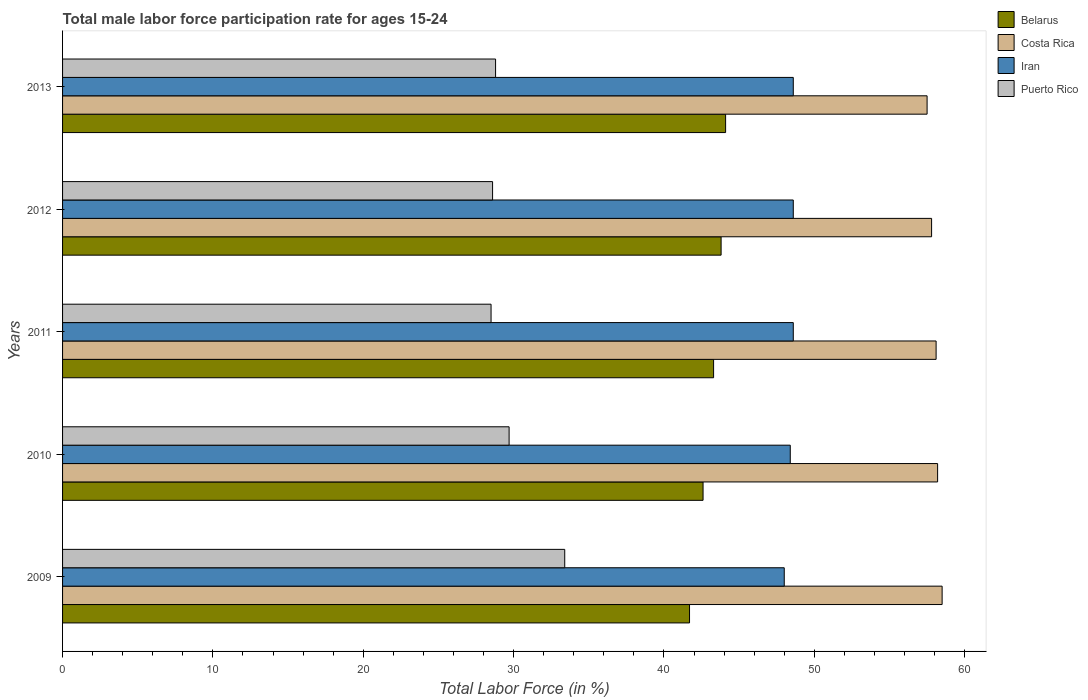How many groups of bars are there?
Your answer should be compact. 5. Are the number of bars on each tick of the Y-axis equal?
Offer a terse response. Yes. How many bars are there on the 1st tick from the bottom?
Ensure brevity in your answer.  4. What is the label of the 3rd group of bars from the top?
Your answer should be very brief. 2011. What is the male labor force participation rate in Costa Rica in 2013?
Give a very brief answer. 57.5. Across all years, what is the maximum male labor force participation rate in Iran?
Offer a terse response. 48.6. Across all years, what is the minimum male labor force participation rate in Belarus?
Make the answer very short. 41.7. In which year was the male labor force participation rate in Puerto Rico maximum?
Your response must be concise. 2009. In which year was the male labor force participation rate in Iran minimum?
Give a very brief answer. 2009. What is the total male labor force participation rate in Iran in the graph?
Your answer should be very brief. 242.2. What is the difference between the male labor force participation rate in Costa Rica in 2010 and that in 2013?
Your response must be concise. 0.7. What is the difference between the male labor force participation rate in Puerto Rico in 2009 and the male labor force participation rate in Iran in 2012?
Provide a succinct answer. -15.2. What is the average male labor force participation rate in Belarus per year?
Offer a terse response. 43.1. In the year 2011, what is the difference between the male labor force participation rate in Iran and male labor force participation rate in Belarus?
Offer a terse response. 5.3. Is the difference between the male labor force participation rate in Iran in 2012 and 2013 greater than the difference between the male labor force participation rate in Belarus in 2012 and 2013?
Your answer should be very brief. Yes. What is the difference between the highest and the second highest male labor force participation rate in Puerto Rico?
Your answer should be very brief. 3.7. What is the difference between the highest and the lowest male labor force participation rate in Costa Rica?
Provide a short and direct response. 1. Is the sum of the male labor force participation rate in Puerto Rico in 2009 and 2013 greater than the maximum male labor force participation rate in Belarus across all years?
Make the answer very short. Yes. What does the 2nd bar from the top in 2011 represents?
Offer a terse response. Iran. What does the 1st bar from the bottom in 2011 represents?
Offer a terse response. Belarus. How many bars are there?
Make the answer very short. 20. Are all the bars in the graph horizontal?
Your answer should be compact. Yes. What is the difference between two consecutive major ticks on the X-axis?
Keep it short and to the point. 10. Does the graph contain grids?
Provide a succinct answer. No. How many legend labels are there?
Offer a very short reply. 4. What is the title of the graph?
Your answer should be compact. Total male labor force participation rate for ages 15-24. What is the label or title of the X-axis?
Your answer should be compact. Total Labor Force (in %). What is the Total Labor Force (in %) in Belarus in 2009?
Your answer should be very brief. 41.7. What is the Total Labor Force (in %) of Costa Rica in 2009?
Your answer should be very brief. 58.5. What is the Total Labor Force (in %) in Puerto Rico in 2009?
Offer a terse response. 33.4. What is the Total Labor Force (in %) of Belarus in 2010?
Your answer should be very brief. 42.6. What is the Total Labor Force (in %) in Costa Rica in 2010?
Offer a very short reply. 58.2. What is the Total Labor Force (in %) of Iran in 2010?
Offer a terse response. 48.4. What is the Total Labor Force (in %) of Puerto Rico in 2010?
Ensure brevity in your answer.  29.7. What is the Total Labor Force (in %) in Belarus in 2011?
Your response must be concise. 43.3. What is the Total Labor Force (in %) in Costa Rica in 2011?
Ensure brevity in your answer.  58.1. What is the Total Labor Force (in %) in Iran in 2011?
Provide a short and direct response. 48.6. What is the Total Labor Force (in %) of Belarus in 2012?
Make the answer very short. 43.8. What is the Total Labor Force (in %) in Costa Rica in 2012?
Ensure brevity in your answer.  57.8. What is the Total Labor Force (in %) of Iran in 2012?
Offer a very short reply. 48.6. What is the Total Labor Force (in %) of Puerto Rico in 2012?
Ensure brevity in your answer.  28.6. What is the Total Labor Force (in %) in Belarus in 2013?
Provide a succinct answer. 44.1. What is the Total Labor Force (in %) of Costa Rica in 2013?
Your response must be concise. 57.5. What is the Total Labor Force (in %) of Iran in 2013?
Your response must be concise. 48.6. What is the Total Labor Force (in %) of Puerto Rico in 2013?
Provide a succinct answer. 28.8. Across all years, what is the maximum Total Labor Force (in %) in Belarus?
Give a very brief answer. 44.1. Across all years, what is the maximum Total Labor Force (in %) in Costa Rica?
Your answer should be very brief. 58.5. Across all years, what is the maximum Total Labor Force (in %) of Iran?
Give a very brief answer. 48.6. Across all years, what is the maximum Total Labor Force (in %) in Puerto Rico?
Offer a terse response. 33.4. Across all years, what is the minimum Total Labor Force (in %) in Belarus?
Offer a terse response. 41.7. Across all years, what is the minimum Total Labor Force (in %) of Costa Rica?
Offer a very short reply. 57.5. Across all years, what is the minimum Total Labor Force (in %) in Iran?
Keep it short and to the point. 48. What is the total Total Labor Force (in %) of Belarus in the graph?
Your answer should be very brief. 215.5. What is the total Total Labor Force (in %) in Costa Rica in the graph?
Your answer should be compact. 290.1. What is the total Total Labor Force (in %) in Iran in the graph?
Make the answer very short. 242.2. What is the total Total Labor Force (in %) of Puerto Rico in the graph?
Your answer should be very brief. 149. What is the difference between the Total Labor Force (in %) of Costa Rica in 2009 and that in 2010?
Offer a very short reply. 0.3. What is the difference between the Total Labor Force (in %) of Belarus in 2009 and that in 2011?
Ensure brevity in your answer.  -1.6. What is the difference between the Total Labor Force (in %) of Costa Rica in 2009 and that in 2011?
Your answer should be very brief. 0.4. What is the difference between the Total Labor Force (in %) of Puerto Rico in 2009 and that in 2011?
Make the answer very short. 4.9. What is the difference between the Total Labor Force (in %) in Iran in 2009 and that in 2012?
Offer a very short reply. -0.6. What is the difference between the Total Labor Force (in %) in Costa Rica in 2009 and that in 2013?
Ensure brevity in your answer.  1. What is the difference between the Total Labor Force (in %) of Iran in 2009 and that in 2013?
Provide a short and direct response. -0.6. What is the difference between the Total Labor Force (in %) of Costa Rica in 2010 and that in 2011?
Your response must be concise. 0.1. What is the difference between the Total Labor Force (in %) in Iran in 2010 and that in 2011?
Your response must be concise. -0.2. What is the difference between the Total Labor Force (in %) in Iran in 2010 and that in 2012?
Your answer should be compact. -0.2. What is the difference between the Total Labor Force (in %) of Puerto Rico in 2010 and that in 2012?
Your answer should be compact. 1.1. What is the difference between the Total Labor Force (in %) in Belarus in 2010 and that in 2013?
Your response must be concise. -1.5. What is the difference between the Total Labor Force (in %) of Puerto Rico in 2010 and that in 2013?
Your answer should be very brief. 0.9. What is the difference between the Total Labor Force (in %) in Belarus in 2011 and that in 2012?
Make the answer very short. -0.5. What is the difference between the Total Labor Force (in %) of Costa Rica in 2011 and that in 2012?
Provide a succinct answer. 0.3. What is the difference between the Total Labor Force (in %) in Costa Rica in 2011 and that in 2013?
Your answer should be compact. 0.6. What is the difference between the Total Labor Force (in %) in Iran in 2011 and that in 2013?
Your answer should be compact. 0. What is the difference between the Total Labor Force (in %) in Belarus in 2012 and that in 2013?
Your answer should be very brief. -0.3. What is the difference between the Total Labor Force (in %) in Costa Rica in 2012 and that in 2013?
Offer a very short reply. 0.3. What is the difference between the Total Labor Force (in %) in Iran in 2012 and that in 2013?
Your answer should be compact. 0. What is the difference between the Total Labor Force (in %) in Belarus in 2009 and the Total Labor Force (in %) in Costa Rica in 2010?
Offer a very short reply. -16.5. What is the difference between the Total Labor Force (in %) in Costa Rica in 2009 and the Total Labor Force (in %) in Iran in 2010?
Give a very brief answer. 10.1. What is the difference between the Total Labor Force (in %) of Costa Rica in 2009 and the Total Labor Force (in %) of Puerto Rico in 2010?
Offer a terse response. 28.8. What is the difference between the Total Labor Force (in %) in Iran in 2009 and the Total Labor Force (in %) in Puerto Rico in 2010?
Keep it short and to the point. 18.3. What is the difference between the Total Labor Force (in %) of Belarus in 2009 and the Total Labor Force (in %) of Costa Rica in 2011?
Provide a short and direct response. -16.4. What is the difference between the Total Labor Force (in %) of Costa Rica in 2009 and the Total Labor Force (in %) of Iran in 2011?
Keep it short and to the point. 9.9. What is the difference between the Total Labor Force (in %) of Costa Rica in 2009 and the Total Labor Force (in %) of Puerto Rico in 2011?
Your answer should be compact. 30. What is the difference between the Total Labor Force (in %) of Iran in 2009 and the Total Labor Force (in %) of Puerto Rico in 2011?
Provide a succinct answer. 19.5. What is the difference between the Total Labor Force (in %) in Belarus in 2009 and the Total Labor Force (in %) in Costa Rica in 2012?
Provide a short and direct response. -16.1. What is the difference between the Total Labor Force (in %) in Belarus in 2009 and the Total Labor Force (in %) in Puerto Rico in 2012?
Provide a short and direct response. 13.1. What is the difference between the Total Labor Force (in %) in Costa Rica in 2009 and the Total Labor Force (in %) in Iran in 2012?
Give a very brief answer. 9.9. What is the difference between the Total Labor Force (in %) in Costa Rica in 2009 and the Total Labor Force (in %) in Puerto Rico in 2012?
Offer a terse response. 29.9. What is the difference between the Total Labor Force (in %) in Belarus in 2009 and the Total Labor Force (in %) in Costa Rica in 2013?
Ensure brevity in your answer.  -15.8. What is the difference between the Total Labor Force (in %) in Belarus in 2009 and the Total Labor Force (in %) in Puerto Rico in 2013?
Provide a succinct answer. 12.9. What is the difference between the Total Labor Force (in %) in Costa Rica in 2009 and the Total Labor Force (in %) in Puerto Rico in 2013?
Make the answer very short. 29.7. What is the difference between the Total Labor Force (in %) of Iran in 2009 and the Total Labor Force (in %) of Puerto Rico in 2013?
Make the answer very short. 19.2. What is the difference between the Total Labor Force (in %) in Belarus in 2010 and the Total Labor Force (in %) in Costa Rica in 2011?
Provide a succinct answer. -15.5. What is the difference between the Total Labor Force (in %) of Costa Rica in 2010 and the Total Labor Force (in %) of Puerto Rico in 2011?
Your answer should be very brief. 29.7. What is the difference between the Total Labor Force (in %) in Belarus in 2010 and the Total Labor Force (in %) in Costa Rica in 2012?
Your response must be concise. -15.2. What is the difference between the Total Labor Force (in %) of Belarus in 2010 and the Total Labor Force (in %) of Iran in 2012?
Ensure brevity in your answer.  -6. What is the difference between the Total Labor Force (in %) of Belarus in 2010 and the Total Labor Force (in %) of Puerto Rico in 2012?
Your response must be concise. 14. What is the difference between the Total Labor Force (in %) of Costa Rica in 2010 and the Total Labor Force (in %) of Iran in 2012?
Your response must be concise. 9.6. What is the difference between the Total Labor Force (in %) in Costa Rica in 2010 and the Total Labor Force (in %) in Puerto Rico in 2012?
Provide a short and direct response. 29.6. What is the difference between the Total Labor Force (in %) of Iran in 2010 and the Total Labor Force (in %) of Puerto Rico in 2012?
Your answer should be very brief. 19.8. What is the difference between the Total Labor Force (in %) of Belarus in 2010 and the Total Labor Force (in %) of Costa Rica in 2013?
Offer a terse response. -14.9. What is the difference between the Total Labor Force (in %) in Costa Rica in 2010 and the Total Labor Force (in %) in Puerto Rico in 2013?
Your response must be concise. 29.4. What is the difference between the Total Labor Force (in %) of Iran in 2010 and the Total Labor Force (in %) of Puerto Rico in 2013?
Give a very brief answer. 19.6. What is the difference between the Total Labor Force (in %) in Belarus in 2011 and the Total Labor Force (in %) in Costa Rica in 2012?
Provide a succinct answer. -14.5. What is the difference between the Total Labor Force (in %) in Costa Rica in 2011 and the Total Labor Force (in %) in Iran in 2012?
Provide a short and direct response. 9.5. What is the difference between the Total Labor Force (in %) of Costa Rica in 2011 and the Total Labor Force (in %) of Puerto Rico in 2012?
Offer a terse response. 29.5. What is the difference between the Total Labor Force (in %) of Iran in 2011 and the Total Labor Force (in %) of Puerto Rico in 2012?
Make the answer very short. 20. What is the difference between the Total Labor Force (in %) of Belarus in 2011 and the Total Labor Force (in %) of Iran in 2013?
Offer a terse response. -5.3. What is the difference between the Total Labor Force (in %) of Belarus in 2011 and the Total Labor Force (in %) of Puerto Rico in 2013?
Provide a succinct answer. 14.5. What is the difference between the Total Labor Force (in %) of Costa Rica in 2011 and the Total Labor Force (in %) of Iran in 2013?
Offer a terse response. 9.5. What is the difference between the Total Labor Force (in %) in Costa Rica in 2011 and the Total Labor Force (in %) in Puerto Rico in 2013?
Keep it short and to the point. 29.3. What is the difference between the Total Labor Force (in %) in Iran in 2011 and the Total Labor Force (in %) in Puerto Rico in 2013?
Your response must be concise. 19.8. What is the difference between the Total Labor Force (in %) in Belarus in 2012 and the Total Labor Force (in %) in Costa Rica in 2013?
Give a very brief answer. -13.7. What is the difference between the Total Labor Force (in %) of Belarus in 2012 and the Total Labor Force (in %) of Puerto Rico in 2013?
Offer a very short reply. 15. What is the difference between the Total Labor Force (in %) in Iran in 2012 and the Total Labor Force (in %) in Puerto Rico in 2013?
Give a very brief answer. 19.8. What is the average Total Labor Force (in %) in Belarus per year?
Make the answer very short. 43.1. What is the average Total Labor Force (in %) in Costa Rica per year?
Your response must be concise. 58.02. What is the average Total Labor Force (in %) in Iran per year?
Keep it short and to the point. 48.44. What is the average Total Labor Force (in %) of Puerto Rico per year?
Your answer should be compact. 29.8. In the year 2009, what is the difference between the Total Labor Force (in %) of Belarus and Total Labor Force (in %) of Costa Rica?
Your answer should be compact. -16.8. In the year 2009, what is the difference between the Total Labor Force (in %) of Belarus and Total Labor Force (in %) of Iran?
Keep it short and to the point. -6.3. In the year 2009, what is the difference between the Total Labor Force (in %) in Belarus and Total Labor Force (in %) in Puerto Rico?
Give a very brief answer. 8.3. In the year 2009, what is the difference between the Total Labor Force (in %) of Costa Rica and Total Labor Force (in %) of Iran?
Offer a very short reply. 10.5. In the year 2009, what is the difference between the Total Labor Force (in %) of Costa Rica and Total Labor Force (in %) of Puerto Rico?
Ensure brevity in your answer.  25.1. In the year 2009, what is the difference between the Total Labor Force (in %) of Iran and Total Labor Force (in %) of Puerto Rico?
Ensure brevity in your answer.  14.6. In the year 2010, what is the difference between the Total Labor Force (in %) of Belarus and Total Labor Force (in %) of Costa Rica?
Provide a short and direct response. -15.6. In the year 2010, what is the difference between the Total Labor Force (in %) in Costa Rica and Total Labor Force (in %) in Iran?
Your response must be concise. 9.8. In the year 2010, what is the difference between the Total Labor Force (in %) in Costa Rica and Total Labor Force (in %) in Puerto Rico?
Your answer should be compact. 28.5. In the year 2010, what is the difference between the Total Labor Force (in %) in Iran and Total Labor Force (in %) in Puerto Rico?
Make the answer very short. 18.7. In the year 2011, what is the difference between the Total Labor Force (in %) of Belarus and Total Labor Force (in %) of Costa Rica?
Keep it short and to the point. -14.8. In the year 2011, what is the difference between the Total Labor Force (in %) of Belarus and Total Labor Force (in %) of Iran?
Provide a succinct answer. -5.3. In the year 2011, what is the difference between the Total Labor Force (in %) in Costa Rica and Total Labor Force (in %) in Iran?
Your answer should be compact. 9.5. In the year 2011, what is the difference between the Total Labor Force (in %) of Costa Rica and Total Labor Force (in %) of Puerto Rico?
Provide a short and direct response. 29.6. In the year 2011, what is the difference between the Total Labor Force (in %) in Iran and Total Labor Force (in %) in Puerto Rico?
Your response must be concise. 20.1. In the year 2012, what is the difference between the Total Labor Force (in %) in Belarus and Total Labor Force (in %) in Puerto Rico?
Provide a succinct answer. 15.2. In the year 2012, what is the difference between the Total Labor Force (in %) of Costa Rica and Total Labor Force (in %) of Iran?
Your answer should be compact. 9.2. In the year 2012, what is the difference between the Total Labor Force (in %) in Costa Rica and Total Labor Force (in %) in Puerto Rico?
Your response must be concise. 29.2. In the year 2012, what is the difference between the Total Labor Force (in %) of Iran and Total Labor Force (in %) of Puerto Rico?
Ensure brevity in your answer.  20. In the year 2013, what is the difference between the Total Labor Force (in %) of Belarus and Total Labor Force (in %) of Iran?
Keep it short and to the point. -4.5. In the year 2013, what is the difference between the Total Labor Force (in %) of Belarus and Total Labor Force (in %) of Puerto Rico?
Provide a succinct answer. 15.3. In the year 2013, what is the difference between the Total Labor Force (in %) of Costa Rica and Total Labor Force (in %) of Puerto Rico?
Make the answer very short. 28.7. In the year 2013, what is the difference between the Total Labor Force (in %) of Iran and Total Labor Force (in %) of Puerto Rico?
Your answer should be very brief. 19.8. What is the ratio of the Total Labor Force (in %) in Belarus in 2009 to that in 2010?
Ensure brevity in your answer.  0.98. What is the ratio of the Total Labor Force (in %) of Costa Rica in 2009 to that in 2010?
Your answer should be compact. 1.01. What is the ratio of the Total Labor Force (in %) of Puerto Rico in 2009 to that in 2010?
Offer a very short reply. 1.12. What is the ratio of the Total Labor Force (in %) in Belarus in 2009 to that in 2011?
Your response must be concise. 0.96. What is the ratio of the Total Labor Force (in %) in Costa Rica in 2009 to that in 2011?
Provide a short and direct response. 1.01. What is the ratio of the Total Labor Force (in %) in Iran in 2009 to that in 2011?
Offer a terse response. 0.99. What is the ratio of the Total Labor Force (in %) in Puerto Rico in 2009 to that in 2011?
Give a very brief answer. 1.17. What is the ratio of the Total Labor Force (in %) of Belarus in 2009 to that in 2012?
Your answer should be very brief. 0.95. What is the ratio of the Total Labor Force (in %) in Costa Rica in 2009 to that in 2012?
Make the answer very short. 1.01. What is the ratio of the Total Labor Force (in %) of Puerto Rico in 2009 to that in 2012?
Provide a short and direct response. 1.17. What is the ratio of the Total Labor Force (in %) in Belarus in 2009 to that in 2013?
Your answer should be compact. 0.95. What is the ratio of the Total Labor Force (in %) of Costa Rica in 2009 to that in 2013?
Offer a very short reply. 1.02. What is the ratio of the Total Labor Force (in %) of Iran in 2009 to that in 2013?
Offer a terse response. 0.99. What is the ratio of the Total Labor Force (in %) in Puerto Rico in 2009 to that in 2013?
Ensure brevity in your answer.  1.16. What is the ratio of the Total Labor Force (in %) of Belarus in 2010 to that in 2011?
Your answer should be very brief. 0.98. What is the ratio of the Total Labor Force (in %) of Costa Rica in 2010 to that in 2011?
Provide a succinct answer. 1. What is the ratio of the Total Labor Force (in %) of Iran in 2010 to that in 2011?
Your answer should be compact. 1. What is the ratio of the Total Labor Force (in %) of Puerto Rico in 2010 to that in 2011?
Your answer should be compact. 1.04. What is the ratio of the Total Labor Force (in %) in Belarus in 2010 to that in 2012?
Make the answer very short. 0.97. What is the ratio of the Total Labor Force (in %) in Costa Rica in 2010 to that in 2013?
Offer a terse response. 1.01. What is the ratio of the Total Labor Force (in %) of Iran in 2010 to that in 2013?
Provide a succinct answer. 1. What is the ratio of the Total Labor Force (in %) of Puerto Rico in 2010 to that in 2013?
Offer a very short reply. 1.03. What is the ratio of the Total Labor Force (in %) of Costa Rica in 2011 to that in 2012?
Your answer should be very brief. 1.01. What is the ratio of the Total Labor Force (in %) in Puerto Rico in 2011 to that in 2012?
Offer a very short reply. 1. What is the ratio of the Total Labor Force (in %) in Belarus in 2011 to that in 2013?
Make the answer very short. 0.98. What is the ratio of the Total Labor Force (in %) of Costa Rica in 2011 to that in 2013?
Ensure brevity in your answer.  1.01. What is the ratio of the Total Labor Force (in %) of Iran in 2011 to that in 2013?
Your response must be concise. 1. What is the ratio of the Total Labor Force (in %) in Puerto Rico in 2011 to that in 2013?
Offer a very short reply. 0.99. What is the ratio of the Total Labor Force (in %) of Puerto Rico in 2012 to that in 2013?
Make the answer very short. 0.99. What is the difference between the highest and the second highest Total Labor Force (in %) in Belarus?
Offer a terse response. 0.3. What is the difference between the highest and the second highest Total Labor Force (in %) in Costa Rica?
Make the answer very short. 0.3. What is the difference between the highest and the second highest Total Labor Force (in %) in Puerto Rico?
Offer a very short reply. 3.7. What is the difference between the highest and the lowest Total Labor Force (in %) in Costa Rica?
Make the answer very short. 1. What is the difference between the highest and the lowest Total Labor Force (in %) of Iran?
Provide a short and direct response. 0.6. 